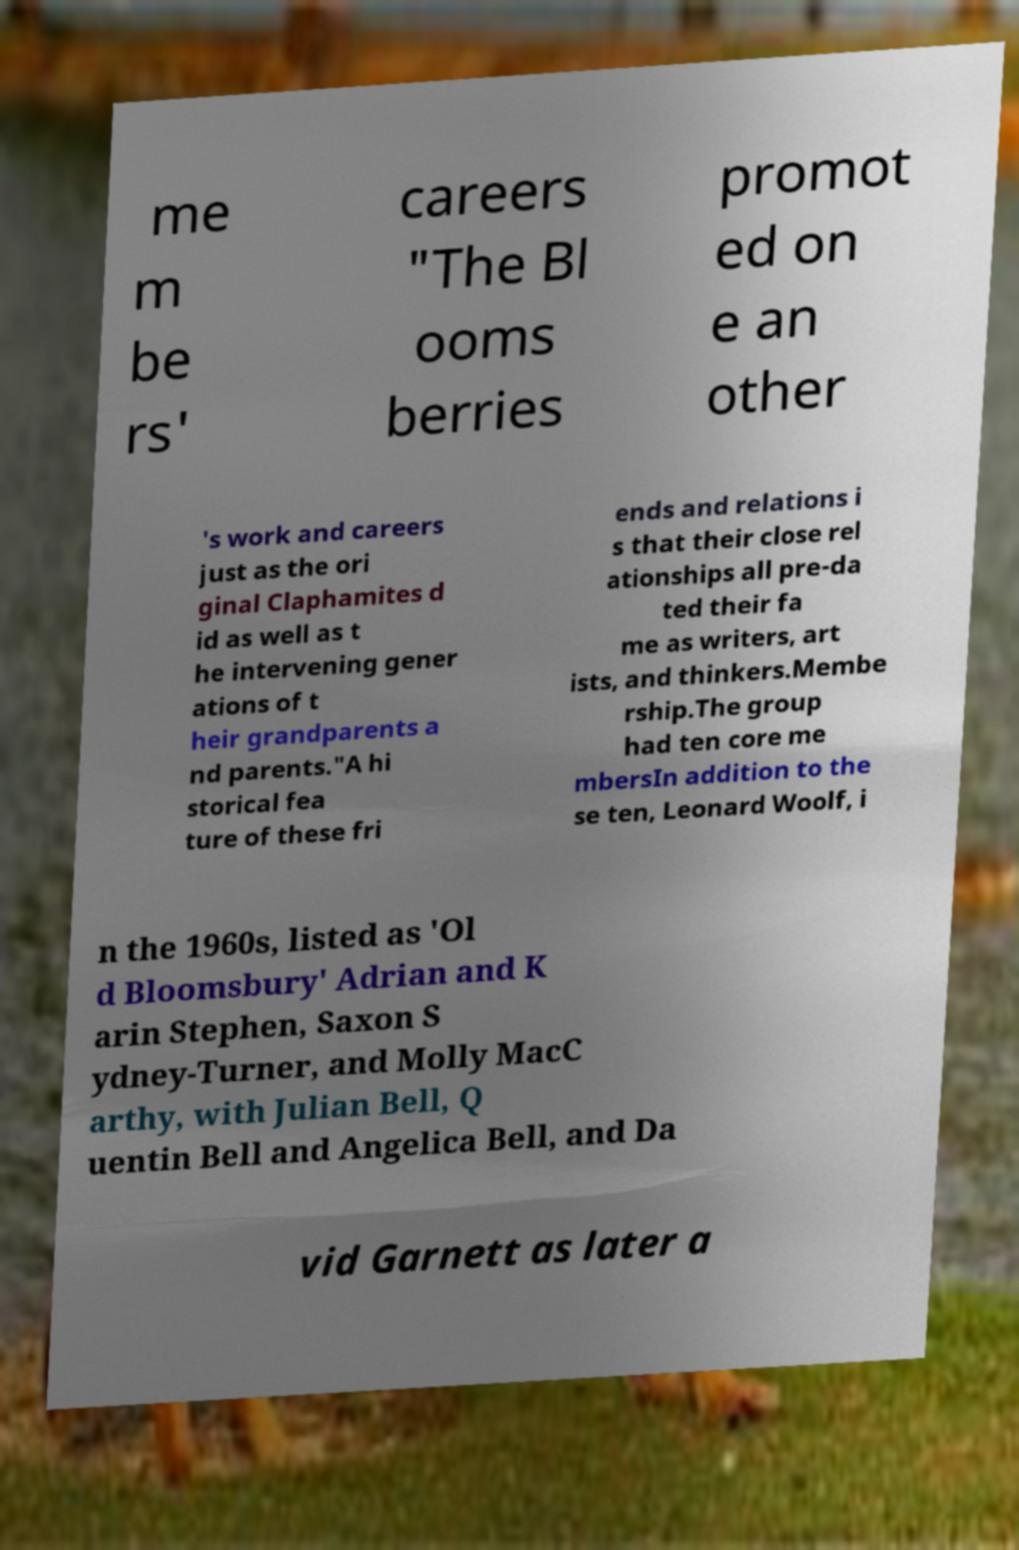Could you extract and type out the text from this image? me m be rs' careers "The Bl ooms berries promot ed on e an other 's work and careers just as the ori ginal Claphamites d id as well as t he intervening gener ations of t heir grandparents a nd parents."A hi storical fea ture of these fri ends and relations i s that their close rel ationships all pre-da ted their fa me as writers, art ists, and thinkers.Membe rship.The group had ten core me mbersIn addition to the se ten, Leonard Woolf, i n the 1960s, listed as 'Ol d Bloomsbury' Adrian and K arin Stephen, Saxon S ydney-Turner, and Molly MacC arthy, with Julian Bell, Q uentin Bell and Angelica Bell, and Da vid Garnett as later a 